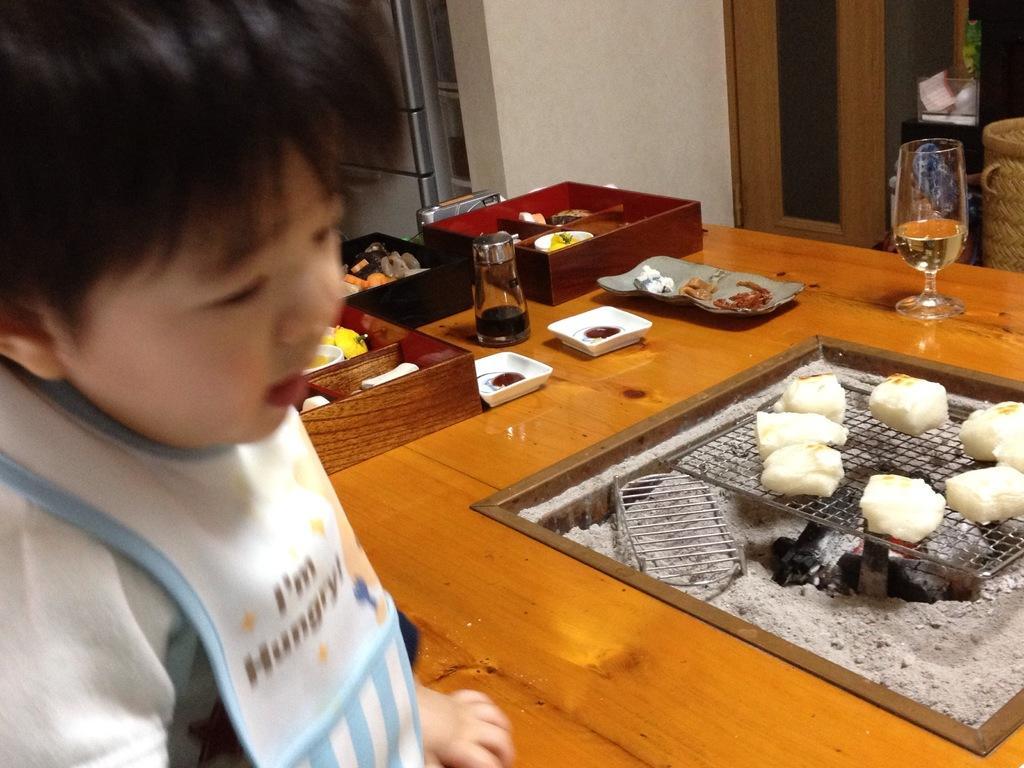Can you describe this image briefly? On the background we can see a wall, refrigerator, window. On the table we can see grill cooking food, plates, bottle, glass. We can see one boy here. 